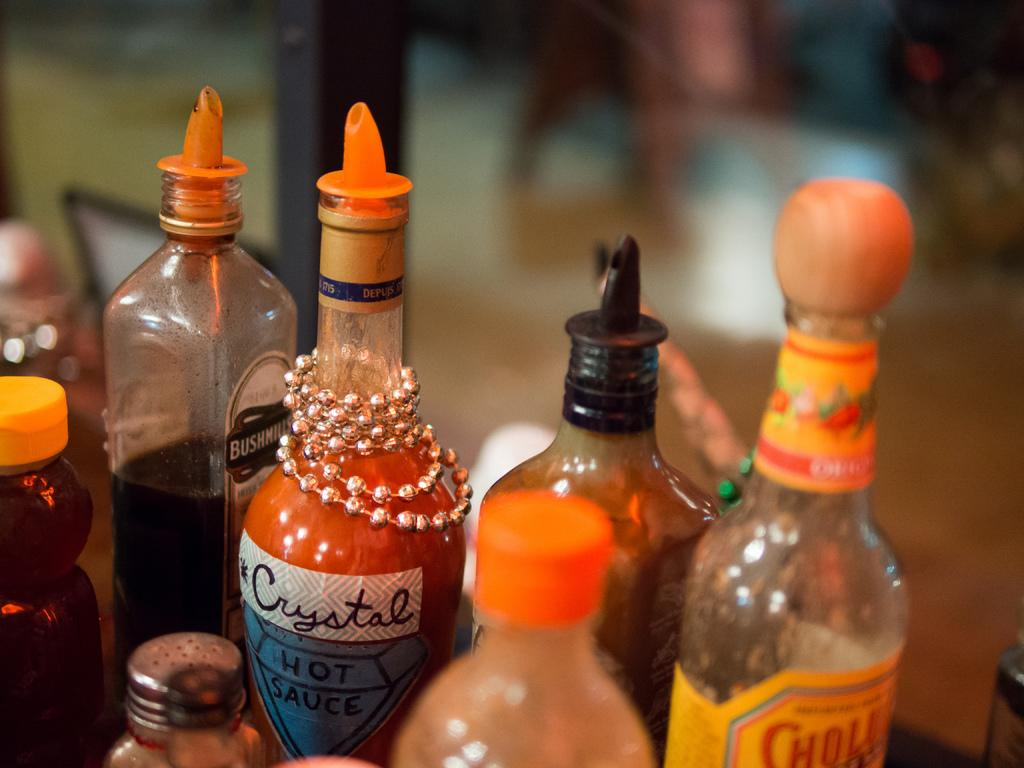What can be seen in the image related to containers? There are bottles of different types in the image. Are there any additional features on some of the bottles? Yes, some bottles have chains on them. What is visible in the background of the image? There is a pillar in the background of the image. How would you describe the background in the image? The background is blurry. What type of finger can be seen holding the bottle in the image? There are no fingers or hands visible in the image; only the bottles and chains are present. Is there any indication of a prison or winter season in the image? No, there is no reference to a prison or winter season in the image. 